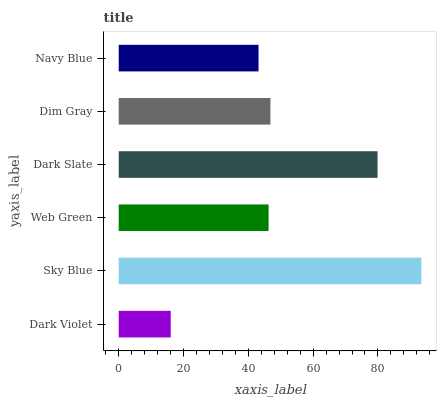Is Dark Violet the minimum?
Answer yes or no. Yes. Is Sky Blue the maximum?
Answer yes or no. Yes. Is Web Green the minimum?
Answer yes or no. No. Is Web Green the maximum?
Answer yes or no. No. Is Sky Blue greater than Web Green?
Answer yes or no. Yes. Is Web Green less than Sky Blue?
Answer yes or no. Yes. Is Web Green greater than Sky Blue?
Answer yes or no. No. Is Sky Blue less than Web Green?
Answer yes or no. No. Is Dim Gray the high median?
Answer yes or no. Yes. Is Web Green the low median?
Answer yes or no. Yes. Is Web Green the high median?
Answer yes or no. No. Is Dim Gray the low median?
Answer yes or no. No. 